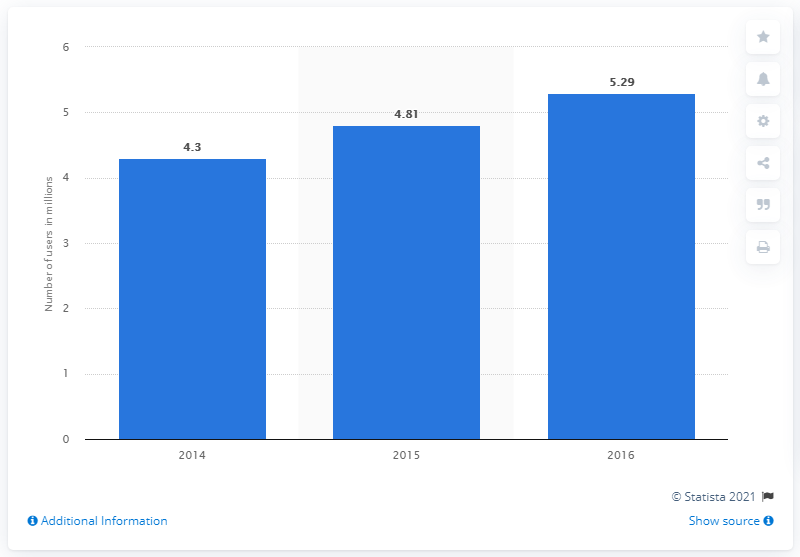Give some essential details in this illustration. In 2015, the number of Twitter users in South Africa was 4.81 million. 